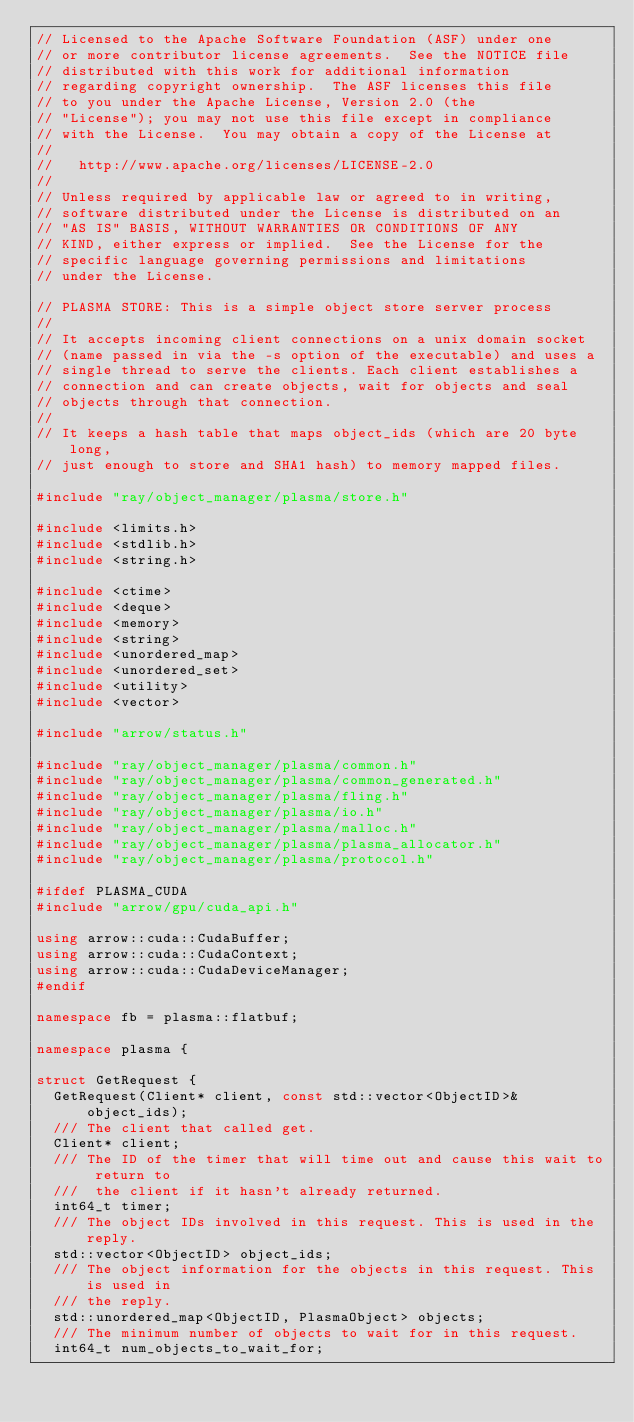Convert code to text. <code><loc_0><loc_0><loc_500><loc_500><_C++_>// Licensed to the Apache Software Foundation (ASF) under one
// or more contributor license agreements.  See the NOTICE file
// distributed with this work for additional information
// regarding copyright ownership.  The ASF licenses this file
// to you under the Apache License, Version 2.0 (the
// "License"); you may not use this file except in compliance
// with the License.  You may obtain a copy of the License at
//
//   http://www.apache.org/licenses/LICENSE-2.0
//
// Unless required by applicable law or agreed to in writing,
// software distributed under the License is distributed on an
// "AS IS" BASIS, WITHOUT WARRANTIES OR CONDITIONS OF ANY
// KIND, either express or implied.  See the License for the
// specific language governing permissions and limitations
// under the License.

// PLASMA STORE: This is a simple object store server process
//
// It accepts incoming client connections on a unix domain socket
// (name passed in via the -s option of the executable) and uses a
// single thread to serve the clients. Each client establishes a
// connection and can create objects, wait for objects and seal
// objects through that connection.
//
// It keeps a hash table that maps object_ids (which are 20 byte long,
// just enough to store and SHA1 hash) to memory mapped files.

#include "ray/object_manager/plasma/store.h"

#include <limits.h>
#include <stdlib.h>
#include <string.h>

#include <ctime>
#include <deque>
#include <memory>
#include <string>
#include <unordered_map>
#include <unordered_set>
#include <utility>
#include <vector>

#include "arrow/status.h"

#include "ray/object_manager/plasma/common.h"
#include "ray/object_manager/plasma/common_generated.h"
#include "ray/object_manager/plasma/fling.h"
#include "ray/object_manager/plasma/io.h"
#include "ray/object_manager/plasma/malloc.h"
#include "ray/object_manager/plasma/plasma_allocator.h"
#include "ray/object_manager/plasma/protocol.h"

#ifdef PLASMA_CUDA
#include "arrow/gpu/cuda_api.h"

using arrow::cuda::CudaBuffer;
using arrow::cuda::CudaContext;
using arrow::cuda::CudaDeviceManager;
#endif

namespace fb = plasma::flatbuf;

namespace plasma {

struct GetRequest {
  GetRequest(Client* client, const std::vector<ObjectID>& object_ids);
  /// The client that called get.
  Client* client;
  /// The ID of the timer that will time out and cause this wait to return to
  ///  the client if it hasn't already returned.
  int64_t timer;
  /// The object IDs involved in this request. This is used in the reply.
  std::vector<ObjectID> object_ids;
  /// The object information for the objects in this request. This is used in
  /// the reply.
  std::unordered_map<ObjectID, PlasmaObject> objects;
  /// The minimum number of objects to wait for in this request.
  int64_t num_objects_to_wait_for;</code> 